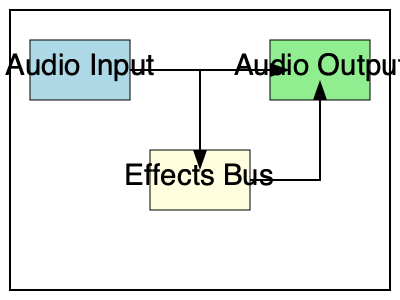In a digital audio workstation (DAW), what is the primary benefit of routing an audio signal through an effects bus instead of applying effects directly to the track? To understand the benefits of routing audio through an effects bus, let's break down the process:

1. Direct effects application:
   - Effects are applied directly to the audio track
   - Each track with effects uses separate processing power
   - Changes to effects require editing each track individually

2. Effects bus routing:
   - An effects bus is created as a separate channel
   - Multiple tracks can be routed to this bus
   - Effects are applied once on the bus, not on individual tracks

3. Benefits of using an effects bus:
   a) Resource efficiency:
      - Processing power is used only once for the bus
      - Reduces overall CPU load, especially for complex effects
   
   b) Consistency:
      - Ensures uniform effect application across multiple tracks
      - Useful for creating cohesive sound in groups of instruments

   c) Flexibility:
      - Allows easy adjustment of effects for multiple tracks simultaneously
      - Facilitates quick A/B testing of different effect configurations

   d) Mix control:
      - Provides a single fader to control the wet/dry balance for multiple tracks
      - Simplifies the mixing process for grouped elements

4. Application in a music production studio:
   - Especially useful for reverbs, delays, and other time-based effects
   - Helps create a sense of space and cohesion in the mix
   - Allows for more efficient workflow and quicker iterations

The primary benefit, considering all these factors, is the improved efficiency in both processing power usage and workflow management, which is crucial for a revolutionary music production studio aiming to optimize its resources and creative process.
Answer: Improved efficiency in processing power usage and workflow management 